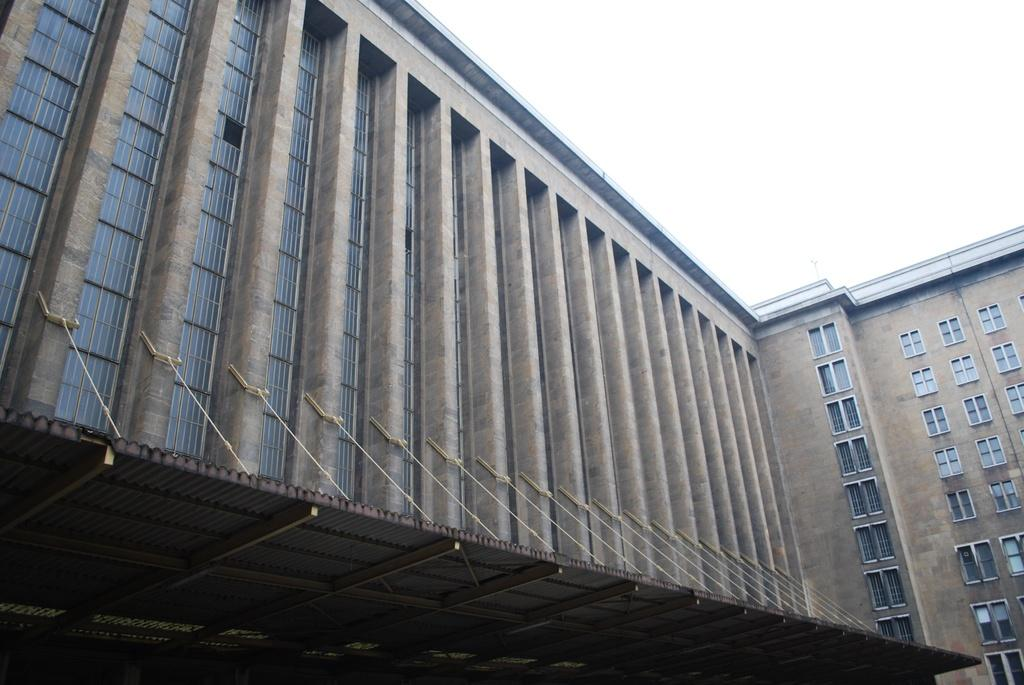What type of structure is present in the image? There is a building in the image. Can you describe the color of the building? The building is brown in color. Is there a beggar standing in front of the building in the image? There is no information about a beggar in the image, so we cannot determine if one is present or not. 